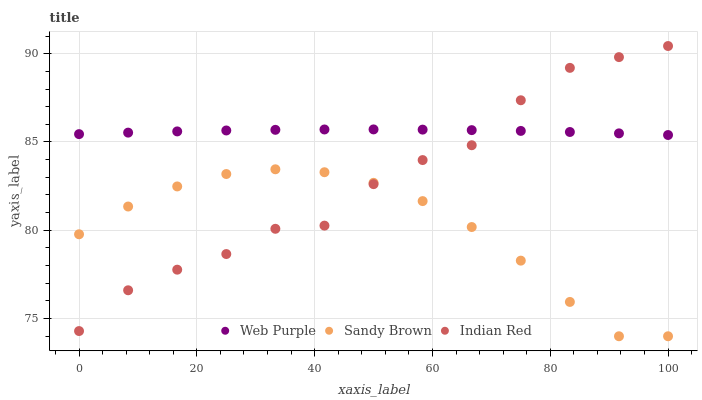Does Sandy Brown have the minimum area under the curve?
Answer yes or no. Yes. Does Web Purple have the maximum area under the curve?
Answer yes or no. Yes. Does Indian Red have the minimum area under the curve?
Answer yes or no. No. Does Indian Red have the maximum area under the curve?
Answer yes or no. No. Is Web Purple the smoothest?
Answer yes or no. Yes. Is Indian Red the roughest?
Answer yes or no. Yes. Is Sandy Brown the smoothest?
Answer yes or no. No. Is Sandy Brown the roughest?
Answer yes or no. No. Does Sandy Brown have the lowest value?
Answer yes or no. Yes. Does Indian Red have the lowest value?
Answer yes or no. No. Does Indian Red have the highest value?
Answer yes or no. Yes. Does Sandy Brown have the highest value?
Answer yes or no. No. Is Sandy Brown less than Web Purple?
Answer yes or no. Yes. Is Web Purple greater than Sandy Brown?
Answer yes or no. Yes. Does Web Purple intersect Indian Red?
Answer yes or no. Yes. Is Web Purple less than Indian Red?
Answer yes or no. No. Is Web Purple greater than Indian Red?
Answer yes or no. No. Does Sandy Brown intersect Web Purple?
Answer yes or no. No. 